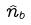<formula> <loc_0><loc_0><loc_500><loc_500>\hat { n } _ { b }</formula> 